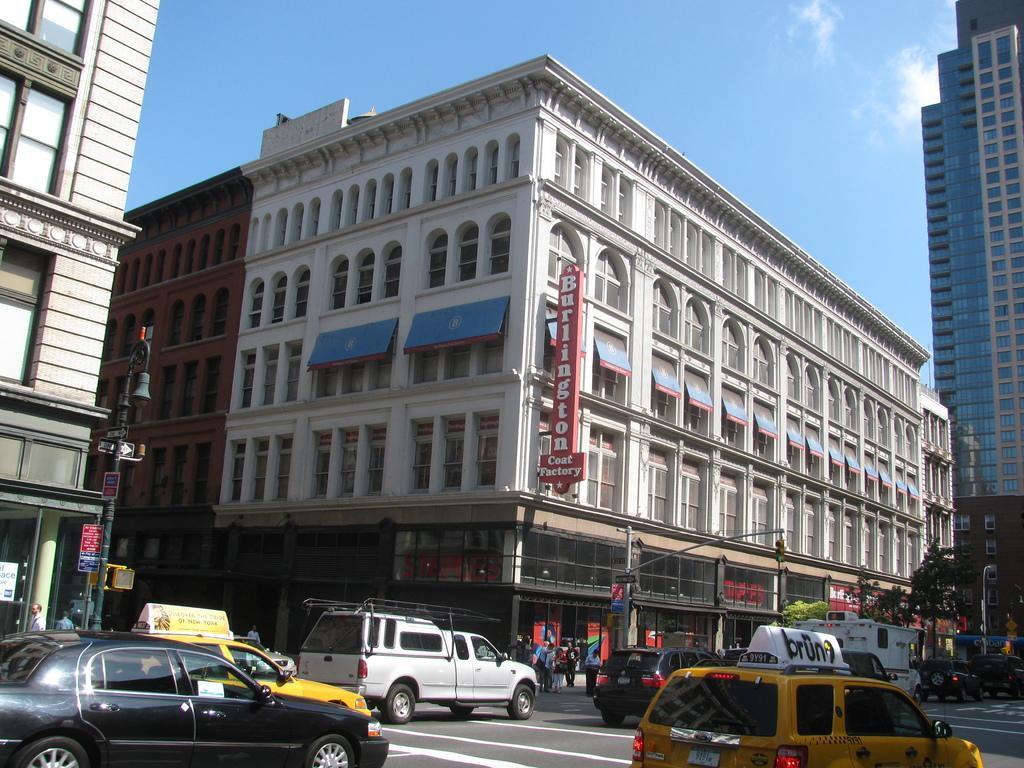<image>
Present a compact description of the photo's key features. A Burlington Coat Factory sign hangs from a building on a busy street corner. 